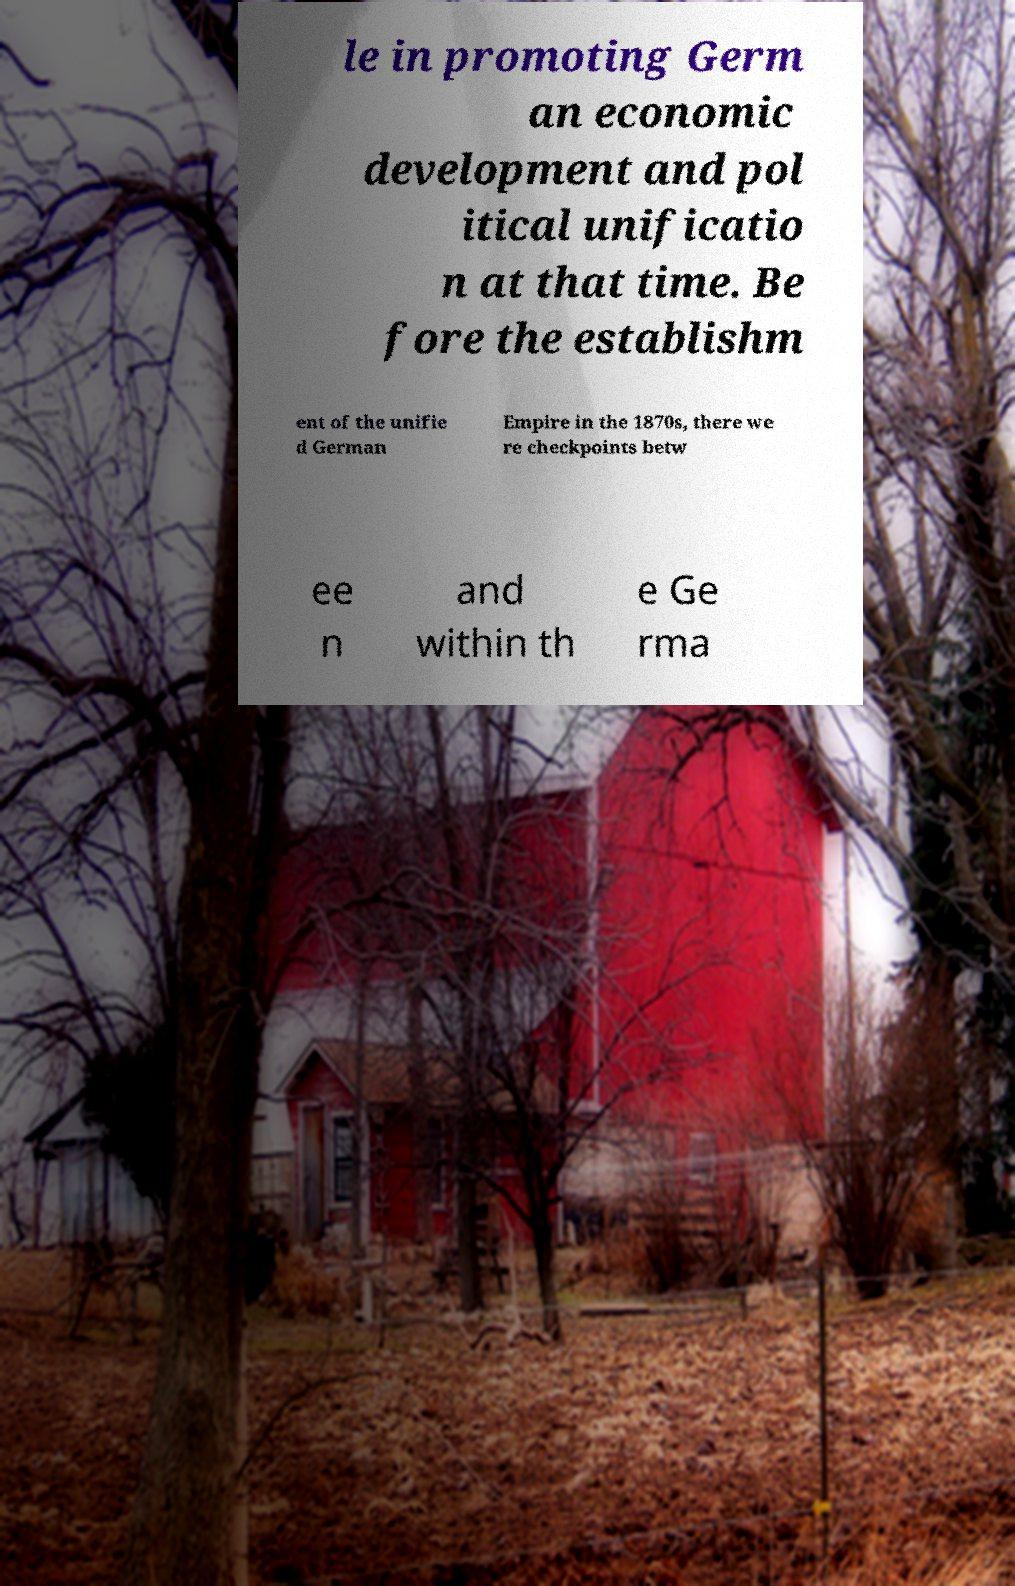Can you read and provide the text displayed in the image?This photo seems to have some interesting text. Can you extract and type it out for me? le in promoting Germ an economic development and pol itical unificatio n at that time. Be fore the establishm ent of the unifie d German Empire in the 1870s, there we re checkpoints betw ee n and within th e Ge rma 